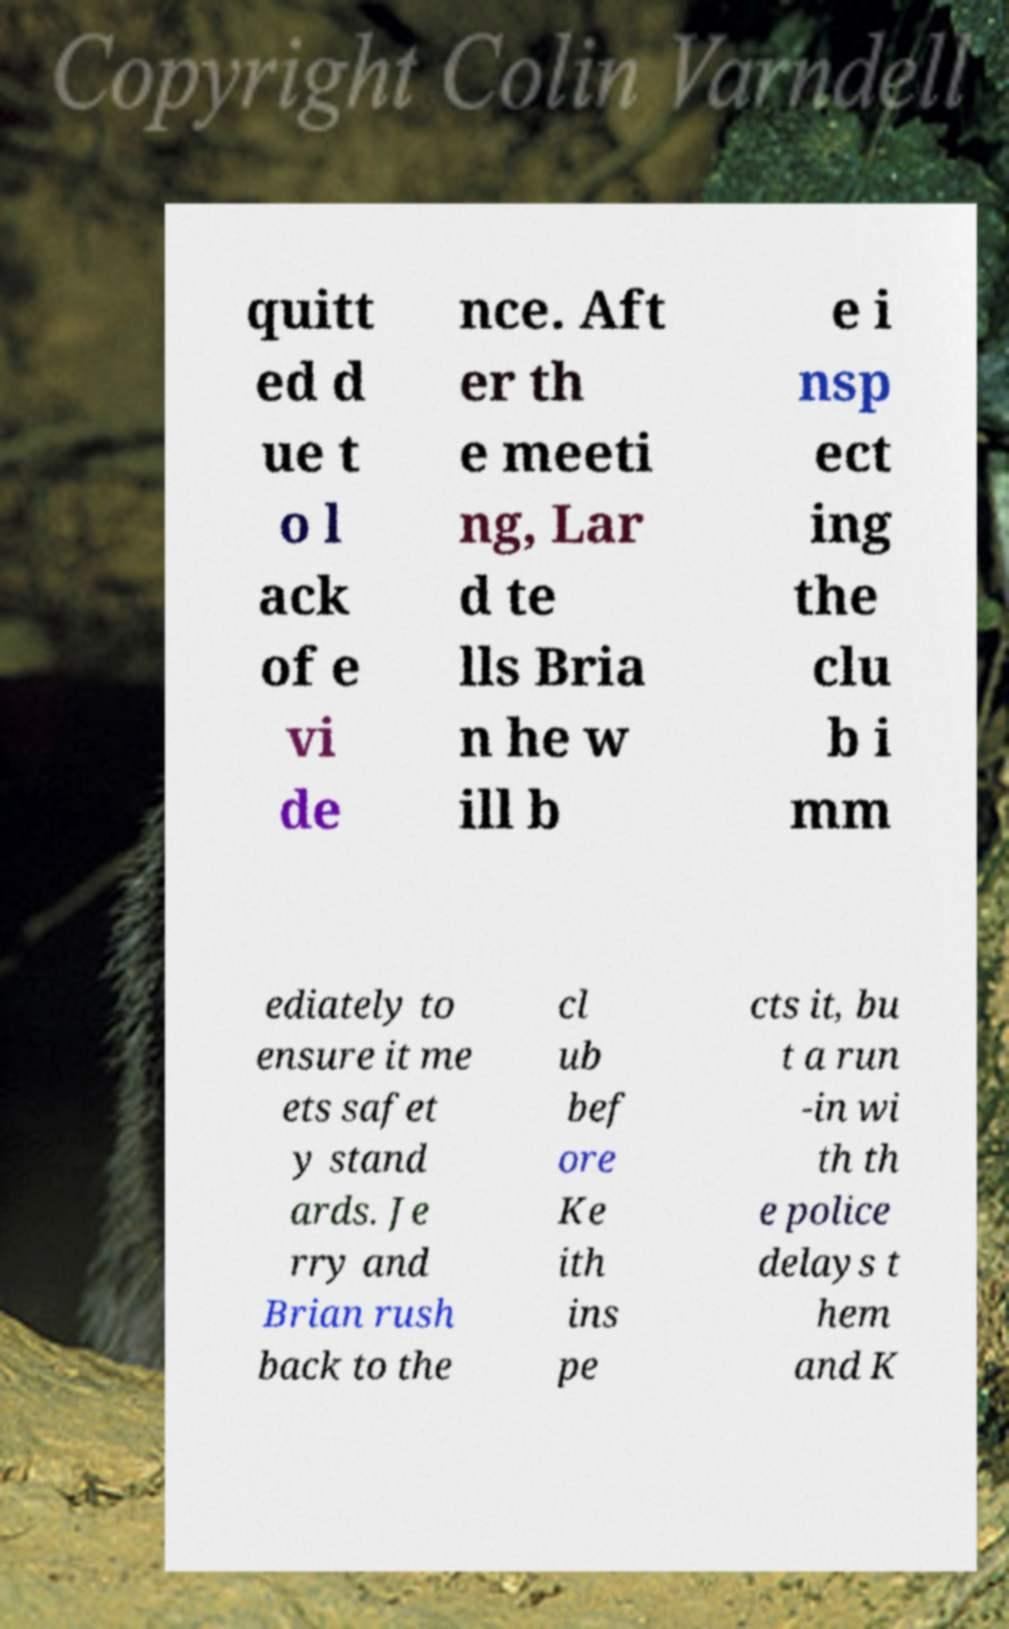For documentation purposes, I need the text within this image transcribed. Could you provide that? quitt ed d ue t o l ack of e vi de nce. Aft er th e meeti ng, Lar d te lls Bria n he w ill b e i nsp ect ing the clu b i mm ediately to ensure it me ets safet y stand ards. Je rry and Brian rush back to the cl ub bef ore Ke ith ins pe cts it, bu t a run -in wi th th e police delays t hem and K 